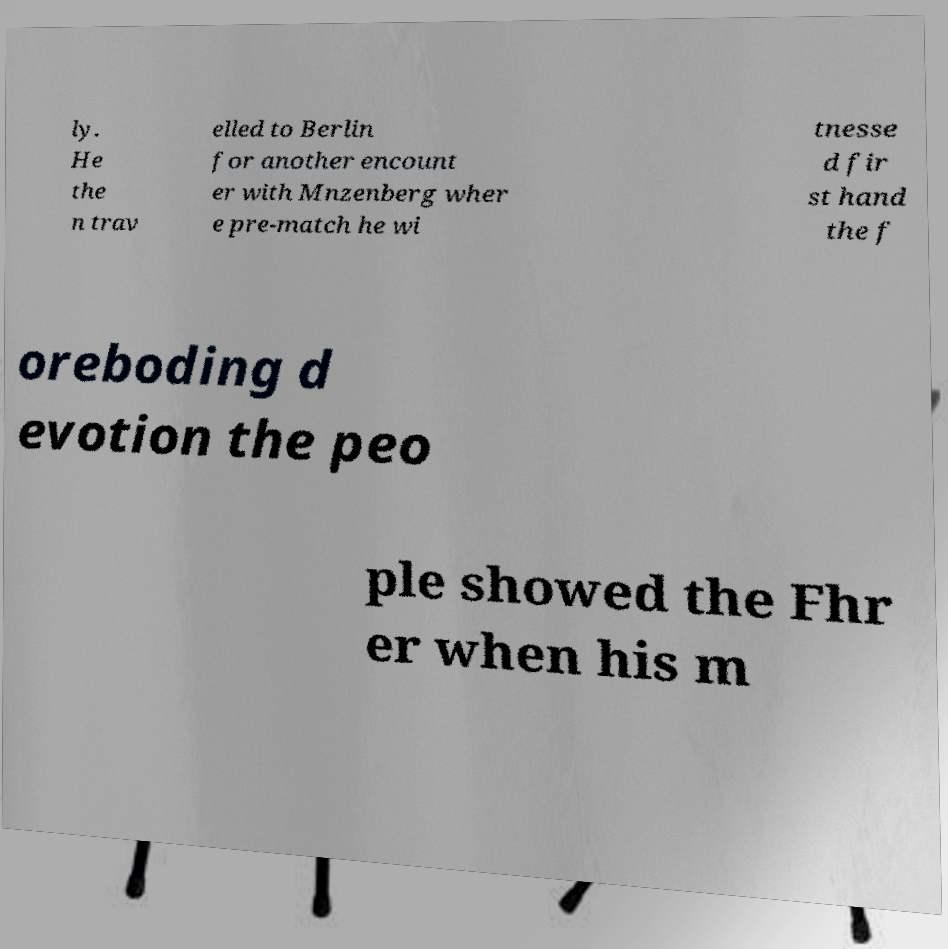Can you read and provide the text displayed in the image?This photo seems to have some interesting text. Can you extract and type it out for me? ly. He the n trav elled to Berlin for another encount er with Mnzenberg wher e pre-match he wi tnesse d fir st hand the f oreboding d evotion the peo ple showed the Fhr er when his m 